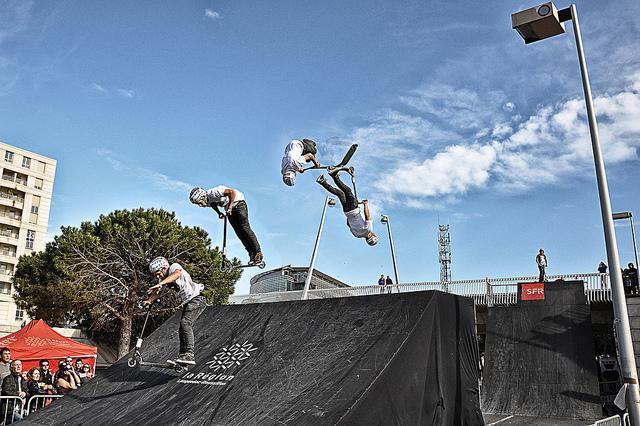How many skater's are shown?
Give a very brief answer. 4. How many people are there?
Give a very brief answer. 3. 